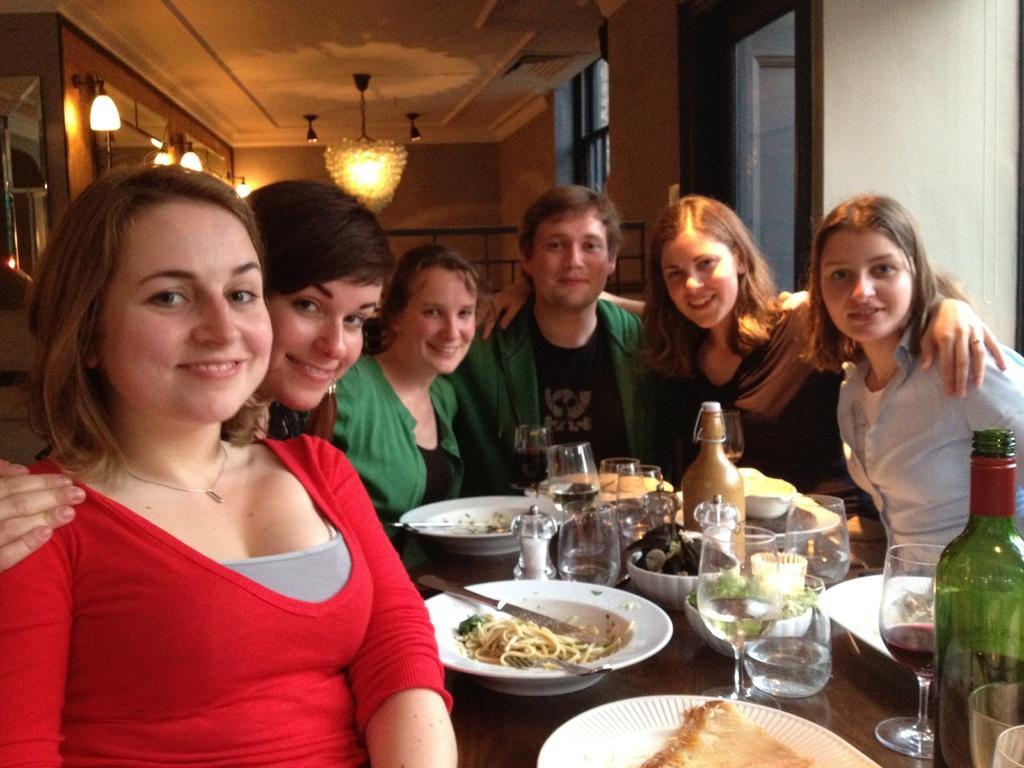Could you give a brief overview of what you see in this image? In this image we can see This six people are sitting around the table. There are few plates with food, forks and knives, glasses, bottles and bowls on the table. In the background of the image we can see chandelier on the ceiling. 